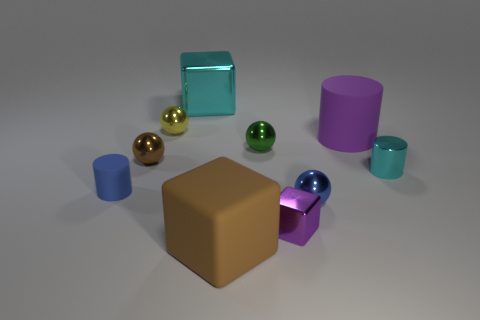The tiny cylinder to the right of the purple object that is left of the blue metallic sphere is what color? cyan 